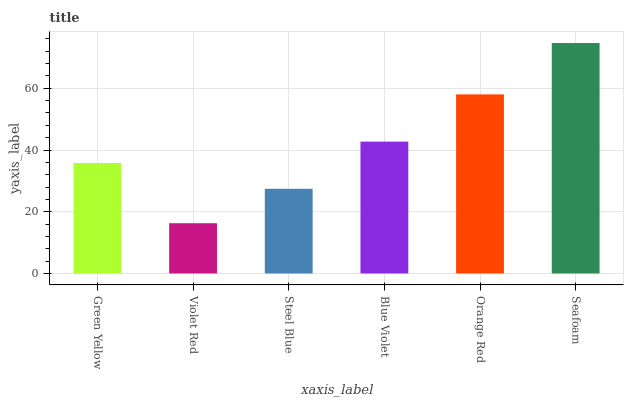Is Violet Red the minimum?
Answer yes or no. Yes. Is Seafoam the maximum?
Answer yes or no. Yes. Is Steel Blue the minimum?
Answer yes or no. No. Is Steel Blue the maximum?
Answer yes or no. No. Is Steel Blue greater than Violet Red?
Answer yes or no. Yes. Is Violet Red less than Steel Blue?
Answer yes or no. Yes. Is Violet Red greater than Steel Blue?
Answer yes or no. No. Is Steel Blue less than Violet Red?
Answer yes or no. No. Is Blue Violet the high median?
Answer yes or no. Yes. Is Green Yellow the low median?
Answer yes or no. Yes. Is Orange Red the high median?
Answer yes or no. No. Is Seafoam the low median?
Answer yes or no. No. 